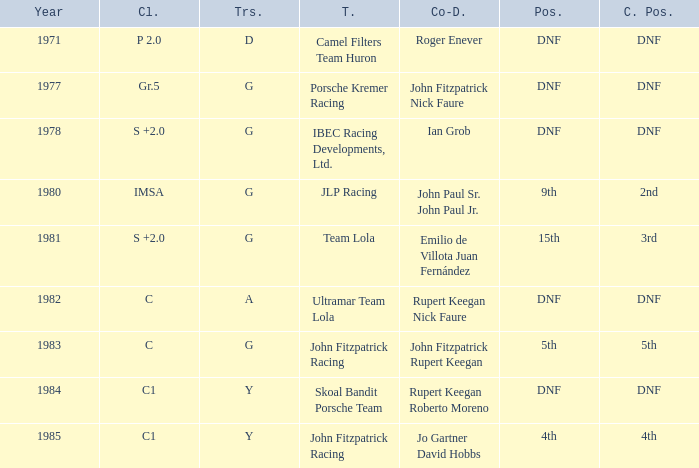What is the earliest year that had a co-driver of Roger Enever? 1971.0. 